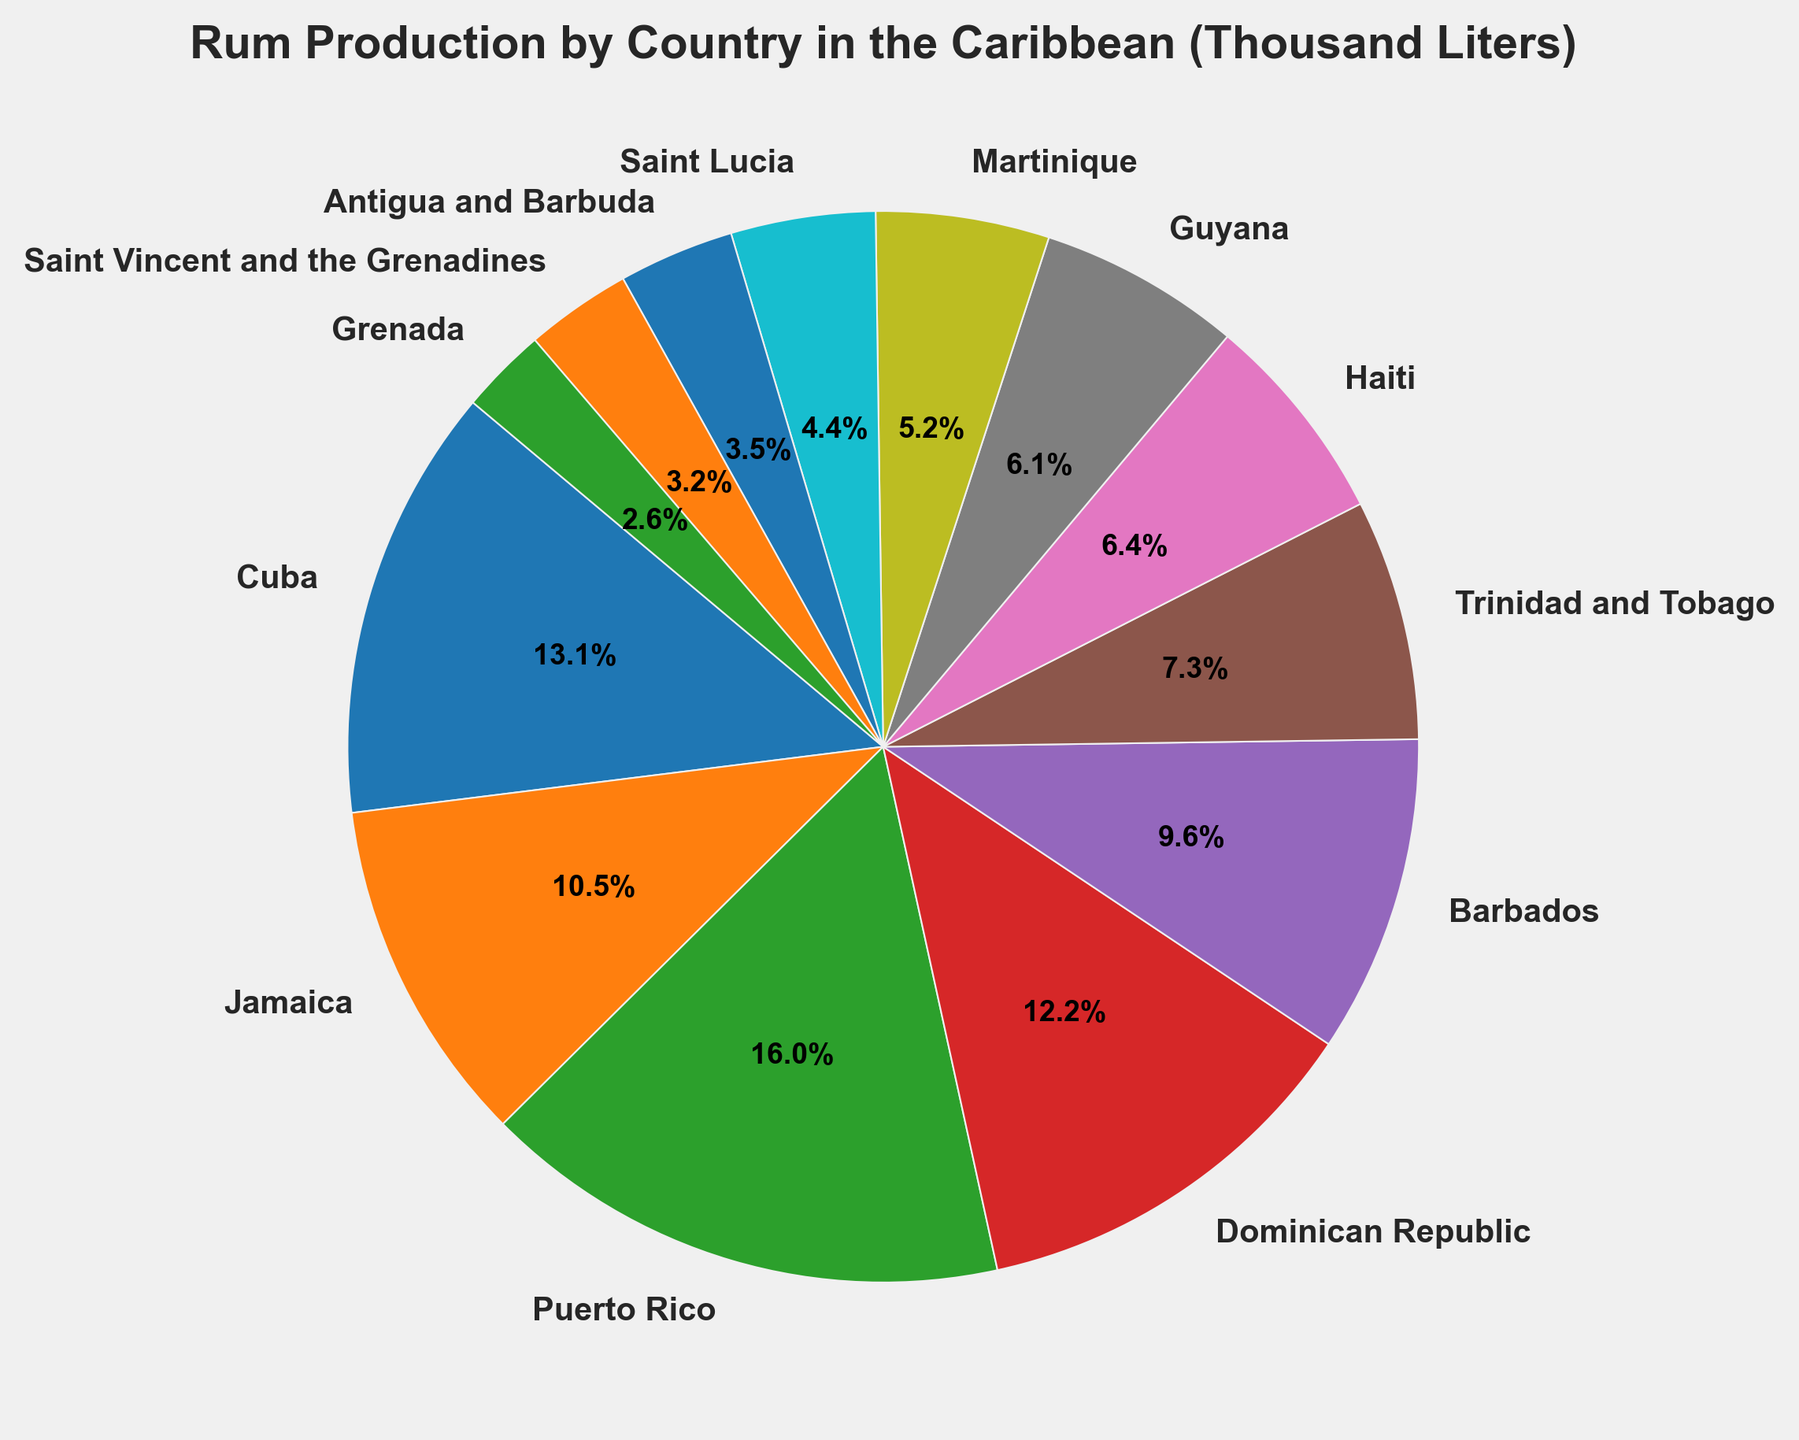Which country has the highest rum production? Look at the size of the slices in the pie chart and the labels. The largest slice belongs to Puerto Rico.
Answer: Puerto Rico Which countries have rum production lower than 15,000 thousand liters? Identify the slices that are smaller and whose labels indicate production below 15,000 thousand liters. The countries are Saint Lucia, Antigua and Barbuda, Saint Vincent and the Grenadines, and Grenada.
Answer: Saint Lucia, Antigua and Barbuda, Saint Vincent and the Grenadines, Grenada Which two countries together produce the most rum? Sum the percentages from the two largest slices in the pie chart. Puerto Rico and Cuba have the two largest slices.
Answer: Puerto Rico and Cuba What is the difference in rum production between Cuba and Jamaica? Find the size of the slices for Cuba and Jamaica, and calculate the difference between the two production values. Cuba produces 45,000 thousand liters, and Jamaica produces 36,000 thousand liters. The difference is 45,000 - 36,000.
Answer: 9,000 What percentage of the total rum production is contributed by Haiti? Identify the slice labeled Haiti and read the percentage from the chart. The label indicates the production size and percentage.
Answer: 4.0% What color represents Martinique on the pie chart? Visually identify the slice labeled "Martinique" and note the associated color. Martinique is shown in light blue.
Answer: light blue Which country has the third highest rum production? Look at the sizes of the slices and identify the third largest slice. The country with the third largest slice is Cuba.
Answer: Cuba Compare the rum production of Trinidad and Tobago and Dominican Republic; which one is higher? Look at the sizes of the slices for Trinidad and Tobago and Dominican Republic and compare their values. The slice for Dominican Republic is larger.
Answer: Dominican Republic What is the combined rum production of Barbados, Trinidad and Tobago, and Guyana? Sum the production values of Barbados, Trinidad and Tobago, and Guyana. The values are 33,000 + 25,000 + 21,000.
Answer: 79,000 What visual attribute shows the distribution of rum production among the countries? Observe the pie chart and identify the visual element that indicates production distribution. The size of the slices represents the distribution of rum production among the countries.
Answer: size of the slices 